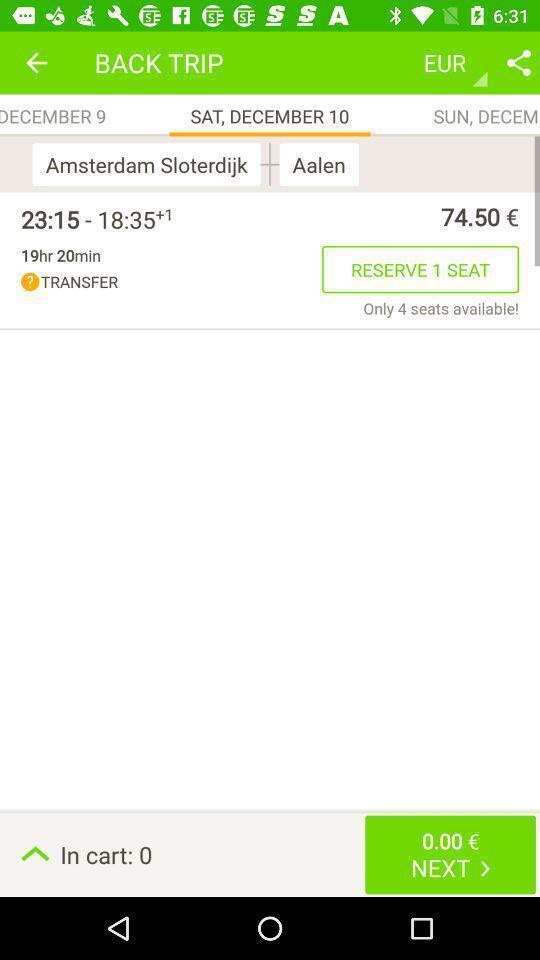Tell me about the visual elements in this screen capture. Screen is showing back trip with reserve seat in application. 